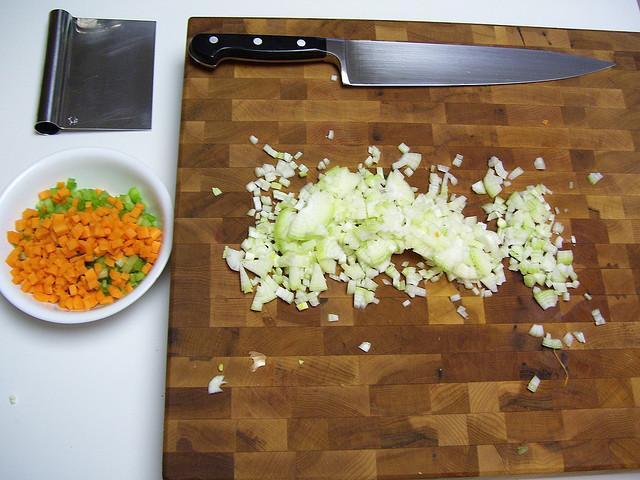How many onions?
Give a very brief answer. 1. 